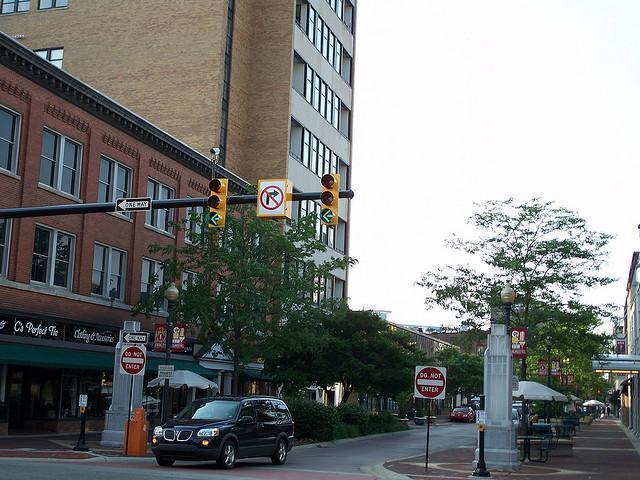Driving straight ahead might cause what?
Indicate the correct response by choosing from the four available options to answer the question.
Options: Accident, flooded car, oil leak, flat tire. Accident. 